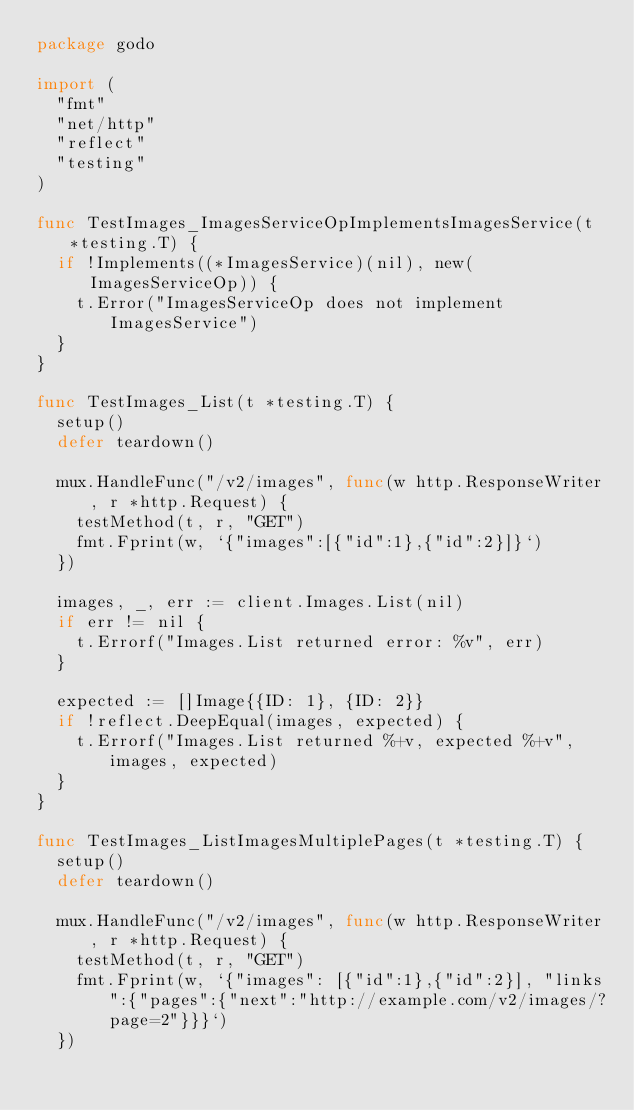<code> <loc_0><loc_0><loc_500><loc_500><_Go_>package godo

import (
	"fmt"
	"net/http"
	"reflect"
	"testing"
)

func TestImages_ImagesServiceOpImplementsImagesService(t *testing.T) {
	if !Implements((*ImagesService)(nil), new(ImagesServiceOp)) {
		t.Error("ImagesServiceOp does not implement ImagesService")
	}
}

func TestImages_List(t *testing.T) {
	setup()
	defer teardown()

	mux.HandleFunc("/v2/images", func(w http.ResponseWriter, r *http.Request) {
		testMethod(t, r, "GET")
		fmt.Fprint(w, `{"images":[{"id":1},{"id":2}]}`)
	})

	images, _, err := client.Images.List(nil)
	if err != nil {
		t.Errorf("Images.List returned error: %v", err)
	}

	expected := []Image{{ID: 1}, {ID: 2}}
	if !reflect.DeepEqual(images, expected) {
		t.Errorf("Images.List returned %+v, expected %+v", images, expected)
	}
}

func TestImages_ListImagesMultiplePages(t *testing.T) {
	setup()
	defer teardown()

	mux.HandleFunc("/v2/images", func(w http.ResponseWriter, r *http.Request) {
		testMethod(t, r, "GET")
		fmt.Fprint(w, `{"images": [{"id":1},{"id":2}], "links":{"pages":{"next":"http://example.com/v2/images/?page=2"}}}`)
	})
</code> 